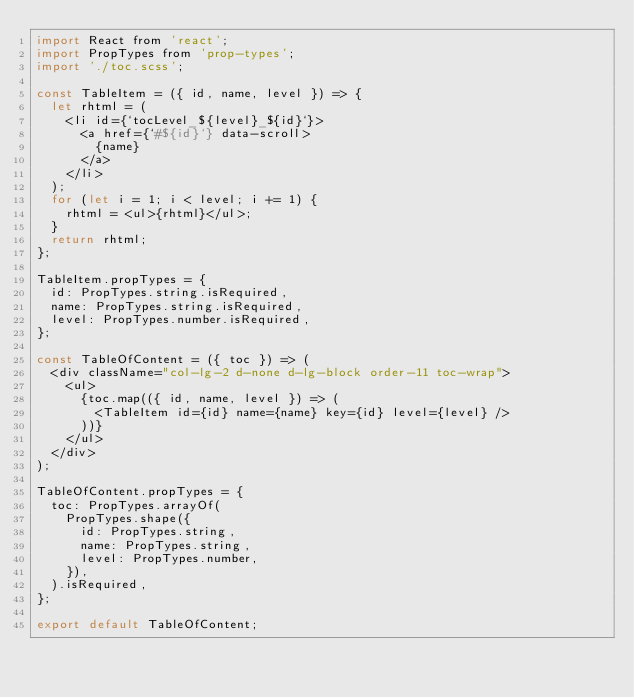<code> <loc_0><loc_0><loc_500><loc_500><_JavaScript_>import React from 'react';
import PropTypes from 'prop-types';
import './toc.scss';

const TableItem = ({ id, name, level }) => {
  let rhtml = (
    <li id={`tocLevel_${level}_${id}`}>
      <a href={`#${id}`} data-scroll>
        {name}
      </a>
    </li>
  );
  for (let i = 1; i < level; i += 1) {
    rhtml = <ul>{rhtml}</ul>;
  }
  return rhtml;
};

TableItem.propTypes = {
  id: PropTypes.string.isRequired,
  name: PropTypes.string.isRequired,
  level: PropTypes.number.isRequired,
};

const TableOfContent = ({ toc }) => (
  <div className="col-lg-2 d-none d-lg-block order-11 toc-wrap">
    <ul>
      {toc.map(({ id, name, level }) => (
        <TableItem id={id} name={name} key={id} level={level} />
      ))}
    </ul>
  </div>
);

TableOfContent.propTypes = {
  toc: PropTypes.arrayOf(
    PropTypes.shape({
      id: PropTypes.string,
      name: PropTypes.string,
      level: PropTypes.number,
    }),
  ).isRequired,
};

export default TableOfContent;
</code> 